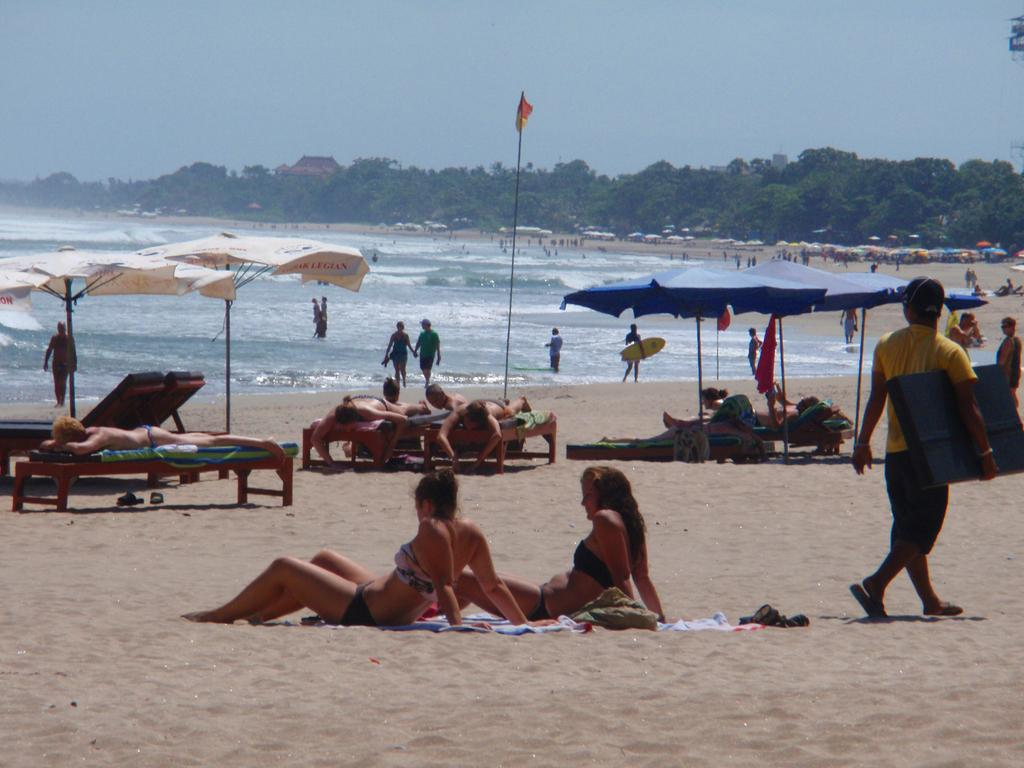What type of location is shown in the image? The image depicts a beach. Are there any natural features besides the beach? Yes, there is a freshwater river in the image. What can be seen in the distance? There are trees and umbrellas in the distance. Are there any people in the image? Yes, there are people standing in the image and people on a bed in the image. What type of sheet is being used to cut the sand in the image? There is no sheet or cutting of sand present in the image. Can you touch the scissors in the image? There are no scissors present in the image to touch. 